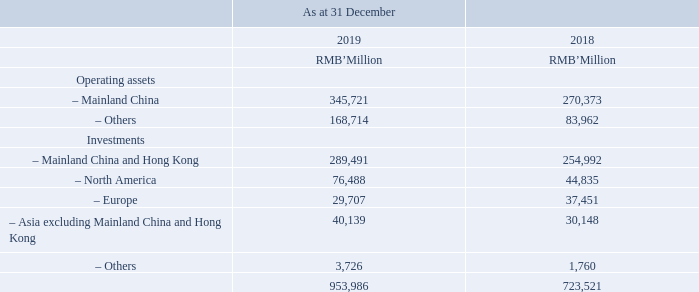(a) Description of segments and principal activities (continued)  The Group also conducts operations in the United States of America (“United States”), Europe and other regions, and holds investments (including investments in associates, investments in joint ventures, FVPL and FVOCI) in various territories. The geographical information on the total assets is as follows:
As at 31 December 2019, the total non-current assets other than financial instruments and deferred tax assets located in Mainland China and other regions amounted to RMB311,386 million (31 December 2018: RMB282,774 million) and RMB136,338 million (31 December 2018: RMB65,057 million), respectively.
All the revenues derived from any single external customer were less than 10% of the Group’s total revenues during the years ended 31 December 2019 and 2018.
How much did the total non-current assets other than financial instruments as at 31 December 2019 amount to? Rmb311,386 million. How much did the deferred tax assets located in Mainland China and other regions as at 31 December 2019 amount to? Rmb136,338 million. How much is the operating assets in mainland china as at 31 December 2019?
Answer scale should be: million. 345,721. How much is the total operating assets as at 31 December 2019?
Answer scale should be: million. 345,721+168,714
Answer: 514435. How much is the difference between 2018 year end and 2019 year end europe investments?
Answer scale should be: million. 37,451-29,707
Answer: 7744. What is the difference between total operating assets and investments of 2018 year end and 2019 year end?
Answer scale should be: million. 953,986-723,521
Answer: 230465. 